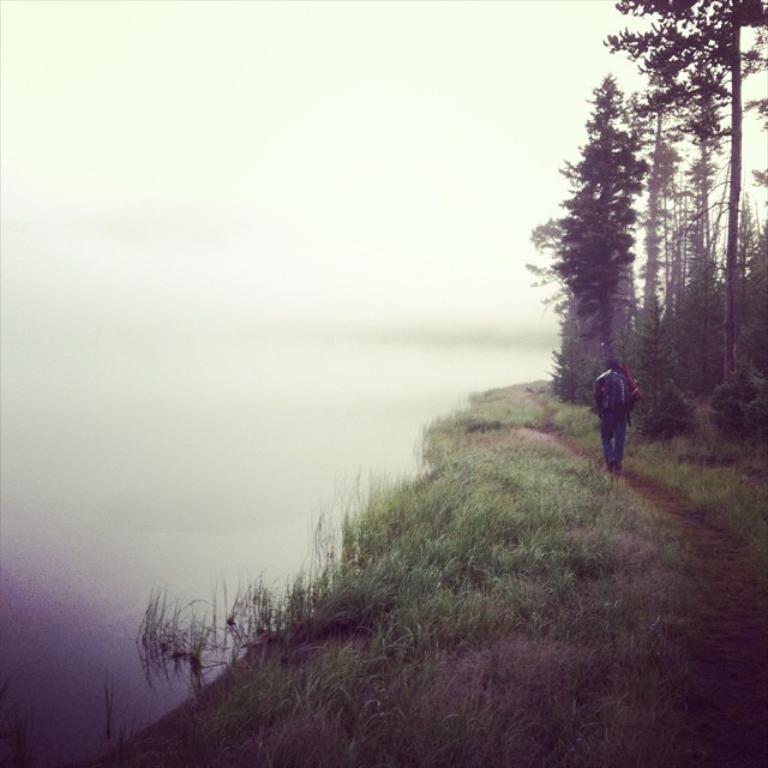How would you summarize this image in a sentence or two? In this image person is walking on the surface of the grass. At the right side there are trees. 